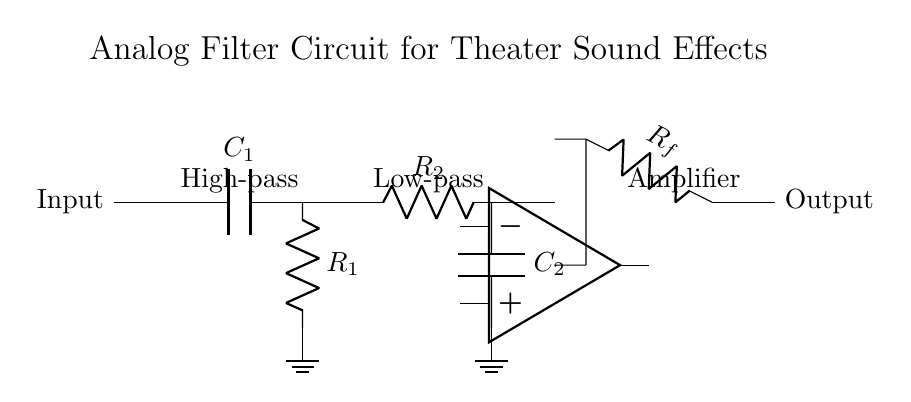What is the input component in this circuit? The input component in this circuit is a capacitor labeled C1, which serves to couple the input signal.
Answer: C1 What type of filter is represented by R1 and C1? R1 and C1 together form a high-pass filter, which blocks low frequencies and allows high frequencies to pass through.
Answer: High-pass What is the purpose of the operational amplifier in this circuit? The operational amplifier is used to amplify the filtered signal after it has passed through the high-pass and low-pass filters, enhancing the overall gain of the circuit.
Answer: Amplification How many resistors are present in this circuit? There are two resistors in the circuit, labeled R1 and R2, used for the high-pass and low-pass filter configurations respectively.
Answer: Two Which components are used to create the low-pass filter? The low-pass filter consists of a resistor R2 and a capacitor C2, which work together to allow low frequencies to pass while attenuating higher frequencies.
Answer: R2 and C2 What is the configuration of the output from the operational amplifier? The output from the operational amplifier is a single signal that conveys the amplified and filtered audio signal to the output terminal.
Answer: Single signal 